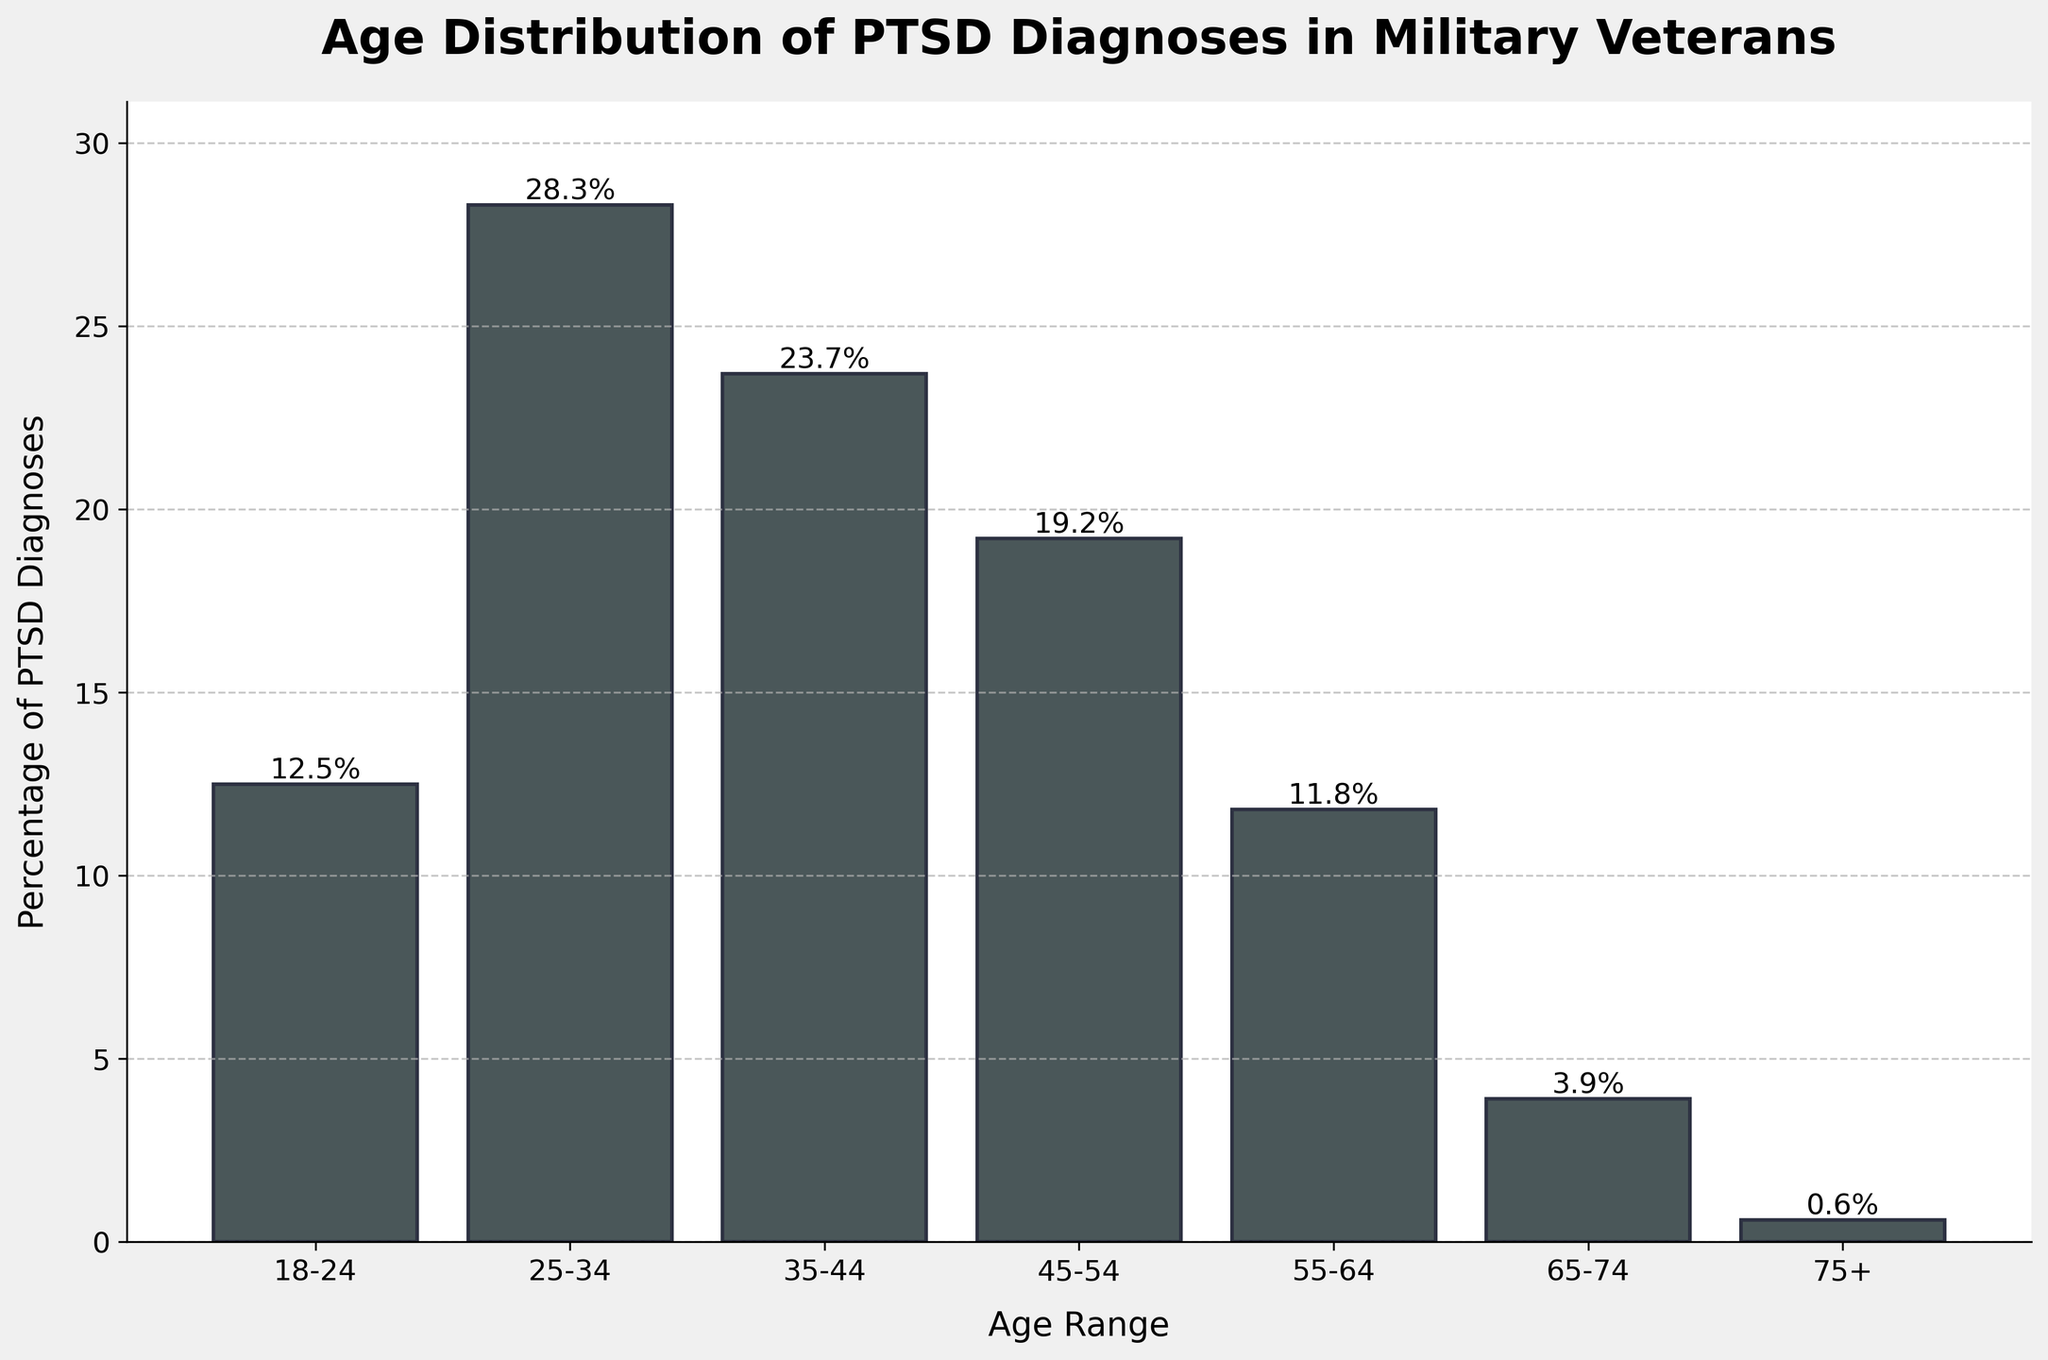What age range has the highest percentage of PTSD diagnoses? The bar chart shows different age ranges and their corresponding percentages of PTSD diagnoses. The highest bar represents the 25-34 age range with 28.3%.
Answer: 25-34 What age range has the lowest percentage of PTSD diagnoses? The bar chart indicates that the 75+ age range has the smallest bar, representing 0.6%.
Answer: 75+ What is the combined percentage of PTSD diagnoses for individuals aged 18-24 and 55-64? The percentage for 18-24 is 12.5%, and for 55-64 it is 11.8%. Adding these together gives 12.5 + 11.8 = 24.3%.
Answer: 24.3% Which age range has a higher percentage of PTSD diagnoses: 35-44 or 45-54? The bar for the 35-44 age range is higher at 23.7%, compared to the 45-54 age range which is 19.2%.
Answer: 35-44 How much higher is the percentage of PTSD diagnoses for ages 25-34 compared to ages 65-74? The percentage for ages 25-34 is 28.3%, and for ages 65-74 it is 3.9%. The difference is 28.3 - 3.9 = 24.4%.
Answer: 24.4% Is the percentage of PTSD diagnoses for individuals aged 35-44 greater than the combined percentage for individuals aged 65-74 and 75+? The percentage for ages 35-44 is 23.7%. The combined percentage for ages 65-74 (3.9%) and 75+ (0.6%) is 3.9 + 0.6 = 4.5%. Since 23.7% is greater than 4.5%, the answer is yes.
Answer: Yes What is the average percentage of PTSD diagnoses across all age ranges? Add all percentages: 12.5 + 28.3 + 23.7 + 19.2 + 11.8 + 3.9 + 0.6 = 100. Then divide by 7 age ranges: 100 / 7 ≈ 14.3.
Answer: 14.3% Between which age ranges does the most significant drop in PTSD diagnosis percentage occur? The most significant drop is between ages 55-64 (11.8%) and ages 65-74 (3.9%). The difference is 11.8 - 3.9 = 7.9.
Answer: 55-64 to 65-74 Counting from the tallest bar to the shortest, which position does the bar for ages 45-54 hold? The tallest bar is for 25-34, followed by 35-44, then 45-54. Therefore, the bar for 45-54 is in 3rd position.
Answer: 3rd 